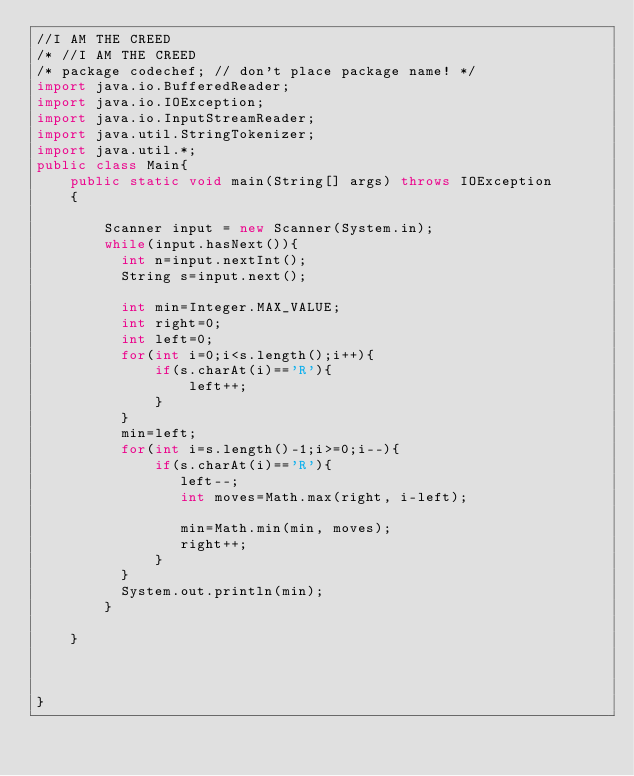<code> <loc_0><loc_0><loc_500><loc_500><_Java_>//I AM THE CREED
/* //I AM THE CREED
/* package codechef; // don't place package name! */
import java.io.BufferedReader; 
import java.io.IOException; 
import java.io.InputStreamReader; 
import java.util.StringTokenizer; 
import java.util.*;
public class Main{
    public static void main(String[] args) throws IOException 
    { 
  
        Scanner input = new Scanner(System.in);
        while(input.hasNext()){
          int n=input.nextInt();
          String s=input.next();
          
          int min=Integer.MAX_VALUE;
          int right=0;
          int left=0;
          for(int i=0;i<s.length();i++){
              if(s.charAt(i)=='R'){
                  left++;
              }
          }
          min=left;
          for(int i=s.length()-1;i>=0;i--){
              if(s.charAt(i)=='R'){
                 left--;
                 int moves=Math.max(right, i-left);
                 
                 min=Math.min(min, moves); 
                 right++;
              }
          }
          System.out.println(min);
        }
        
    }
    


}</code> 